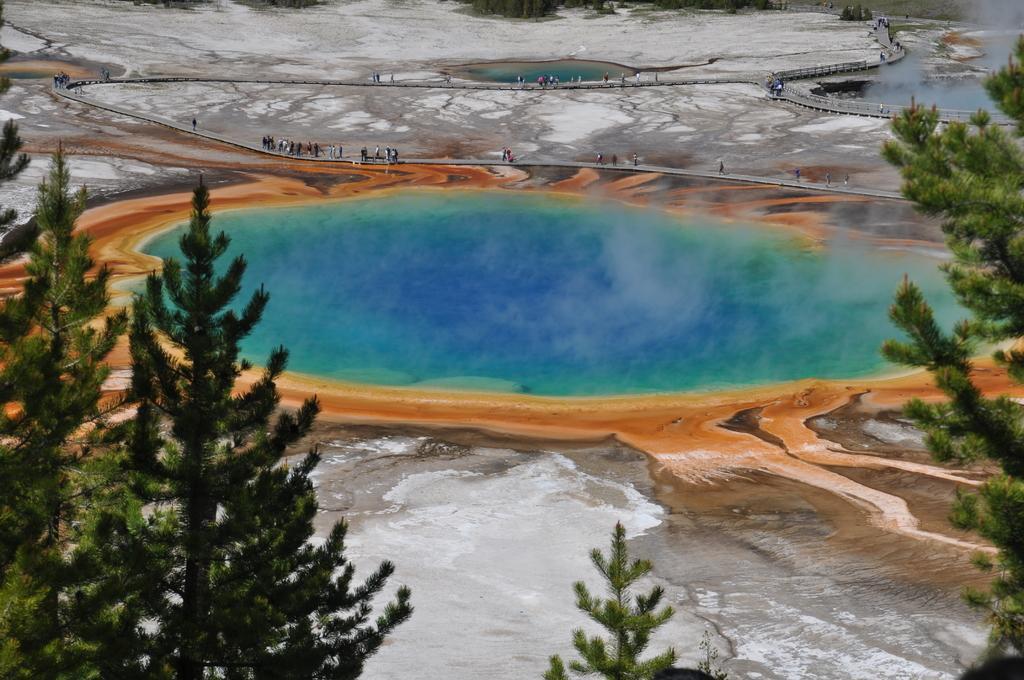How would you summarize this image in a sentence or two? In this picture we can see a lake with blue and green water with smoke coming out of it. The lake is surrounded by sand, trees and rocks. 